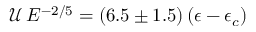<formula> <loc_0><loc_0><loc_500><loc_500>\mathcal { U } \, E ^ { - 2 / 5 } = ( 6 . 5 \pm 1 . 5 ) \, ( \epsilon - \epsilon _ { c } )</formula> 